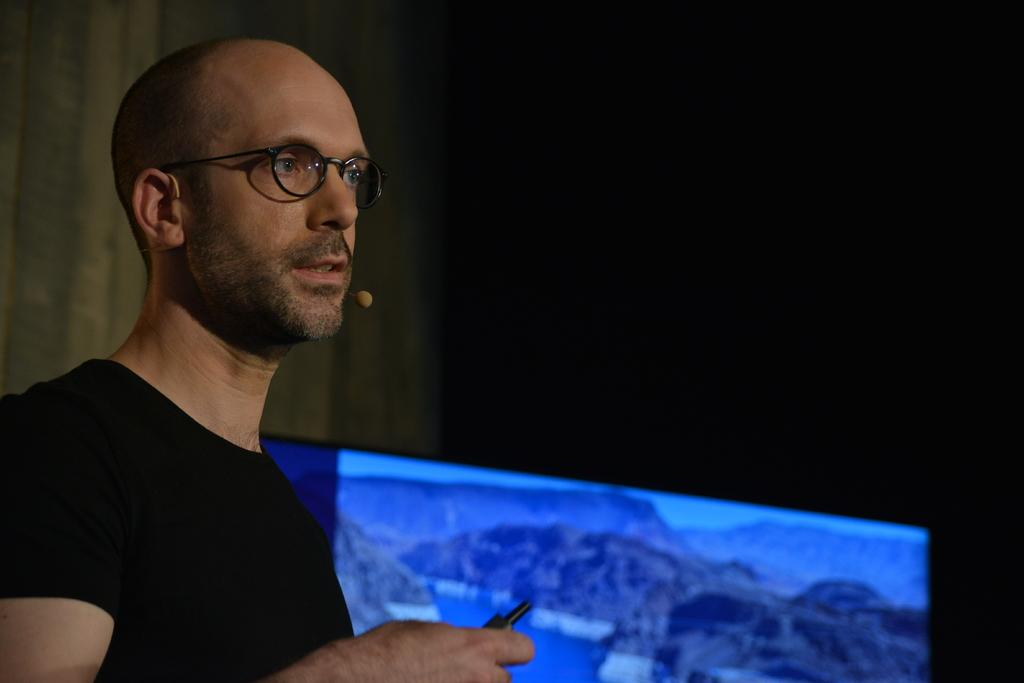Who is present in the image? There is a person in the image. What can be observed about the person's appearance? The person is wearing spectacles. What is the person holding in the image? The person is holding something. What type of device or object is visible in the image? There is a screen in the image. What type of paper can be seen on the person's desk in the image? There is no paper visible on the person's desk in the image. How many beads are present on the person's necklace in the image? There is no necklace or beads present in the image. 